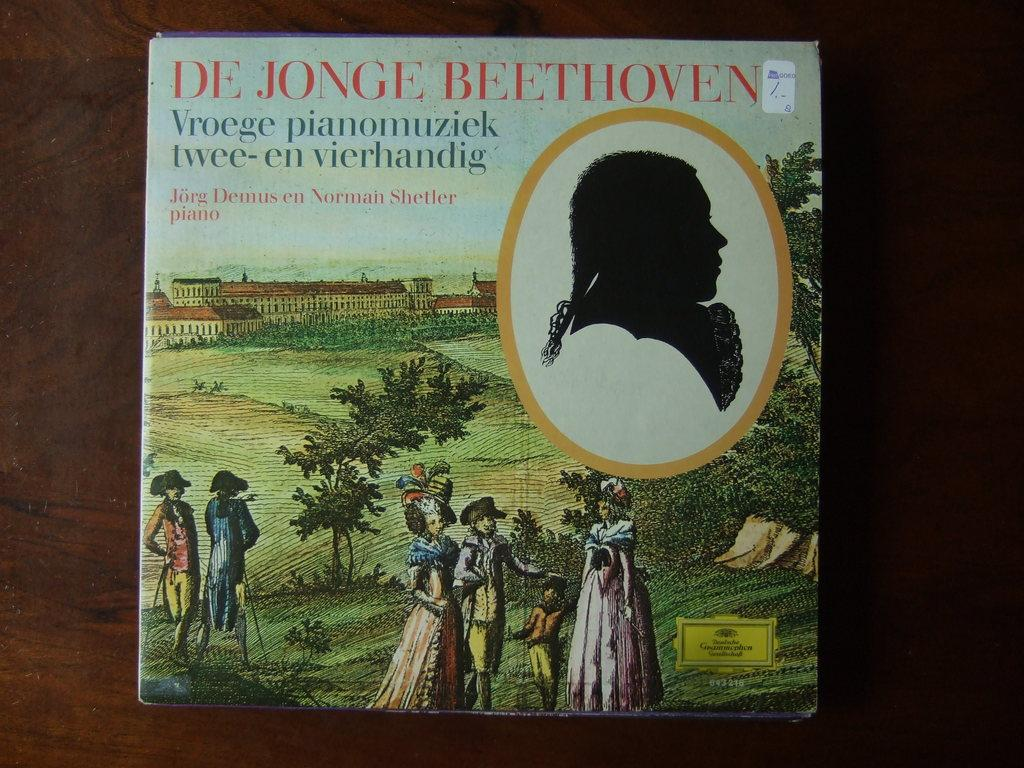<image>
Share a concise interpretation of the image provided. A book about De Jonge Beethoven features people standing in a green field on the cover 